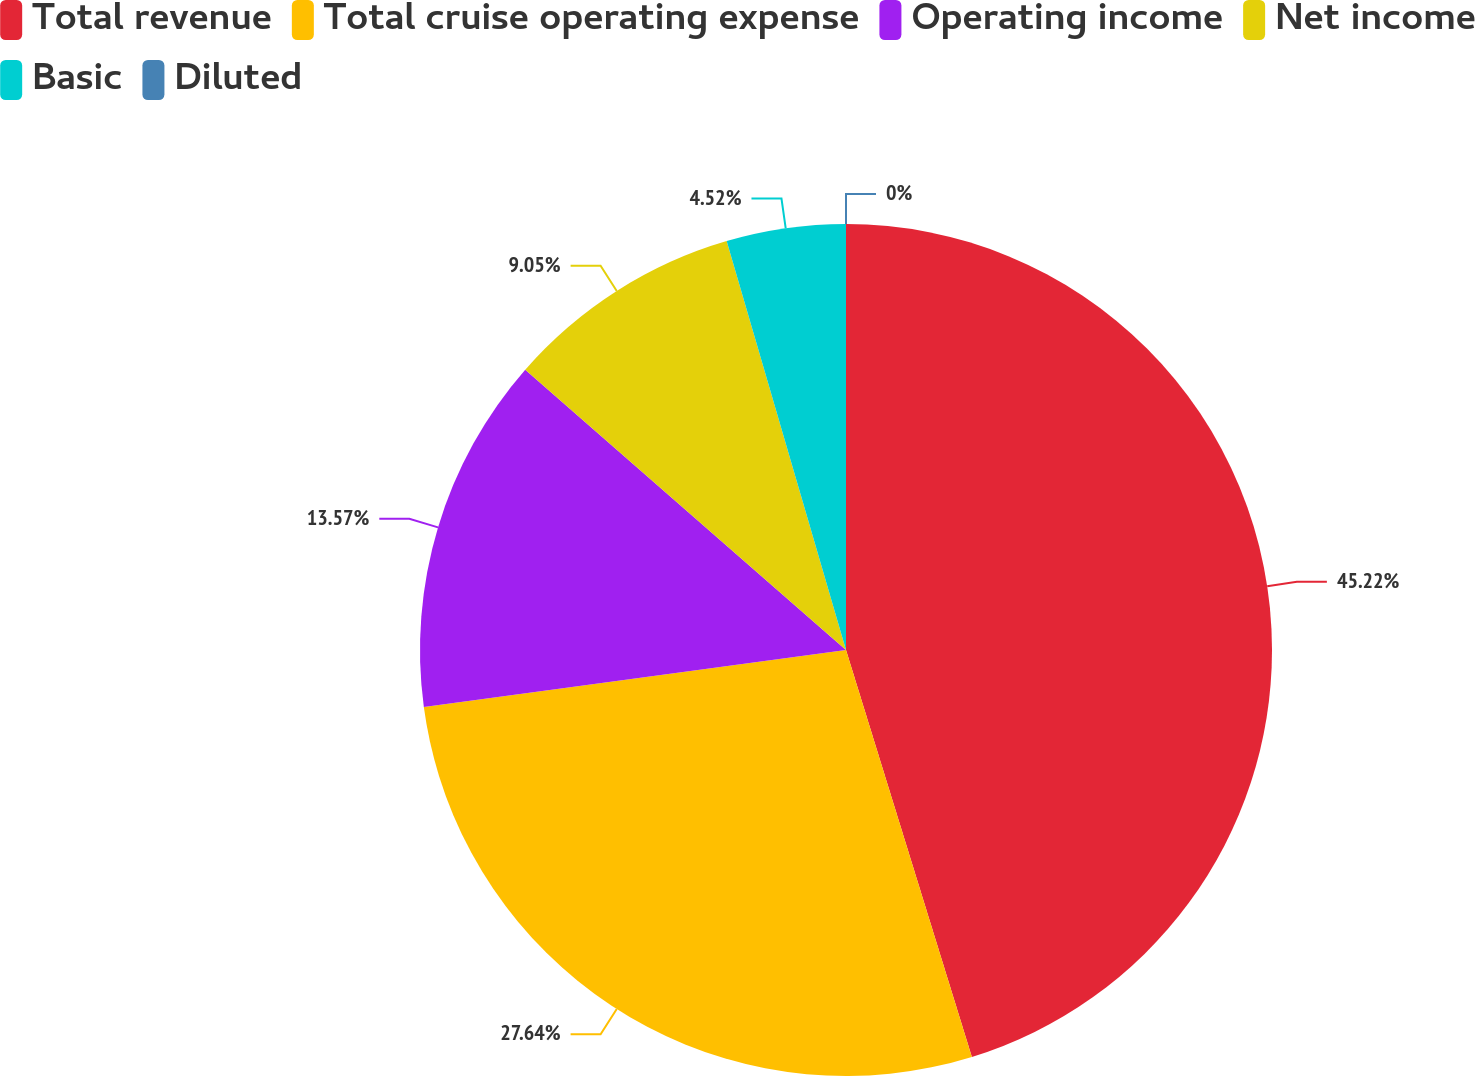Convert chart to OTSL. <chart><loc_0><loc_0><loc_500><loc_500><pie_chart><fcel>Total revenue<fcel>Total cruise operating expense<fcel>Operating income<fcel>Net income<fcel>Basic<fcel>Diluted<nl><fcel>45.23%<fcel>27.64%<fcel>13.57%<fcel>9.05%<fcel>4.52%<fcel>0.0%<nl></chart> 